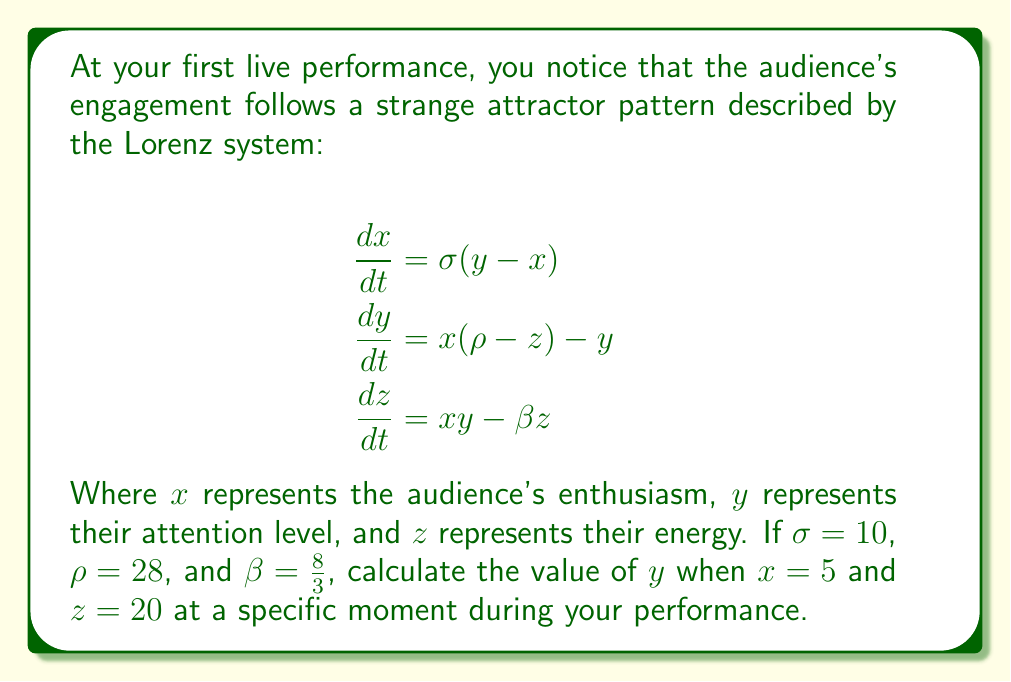Solve this math problem. To solve this problem, we'll use the second equation of the Lorenz system, which relates $x$, $y$, and $z$:

$$\frac{dy}{dt} = x(\rho-z) - y$$

We're looking for the value of $y$ at a specific moment, so we can treat this as an algebraic equation rather than a differential equation. We'll rearrange it to solve for $y$:

1) First, set $\frac{dy}{dt} = 0$, as we're interested in the instantaneous value:

   $0 = x(\rho-z) - y$

2) Rearrange the equation:

   $y = x(\rho-z)$

3) Now, substitute the known values:
   $x = 5$
   $z = 20$
   $\rho = 28$

4) Calculate:

   $y = 5(28-20)$
   $y = 5(8)$
   $y = 40$

Therefore, when $x = 5$ and $z = 20$, the value of $y$ (the audience's attention level) is 40.
Answer: $y = 40$ 